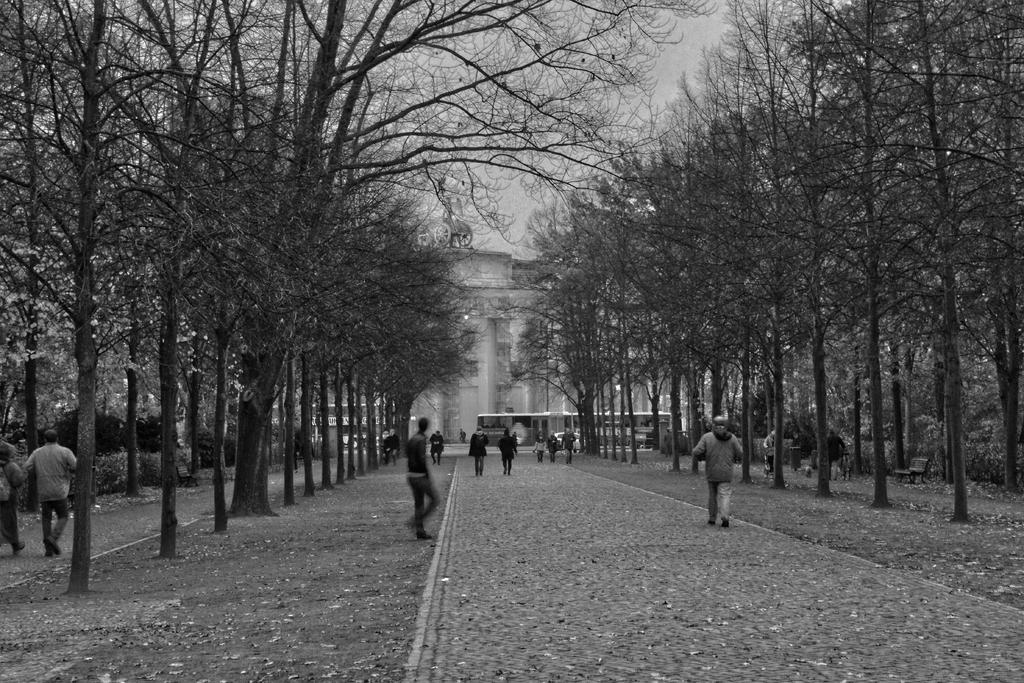What is the color scheme of the image? The image is black and white. What are the people in the image doing? People are walking on paths in the image. What can be seen on either side of the paths? There are trees on either side of the paths. How many chairs can be seen in the image? There are no chairs present in the image. 